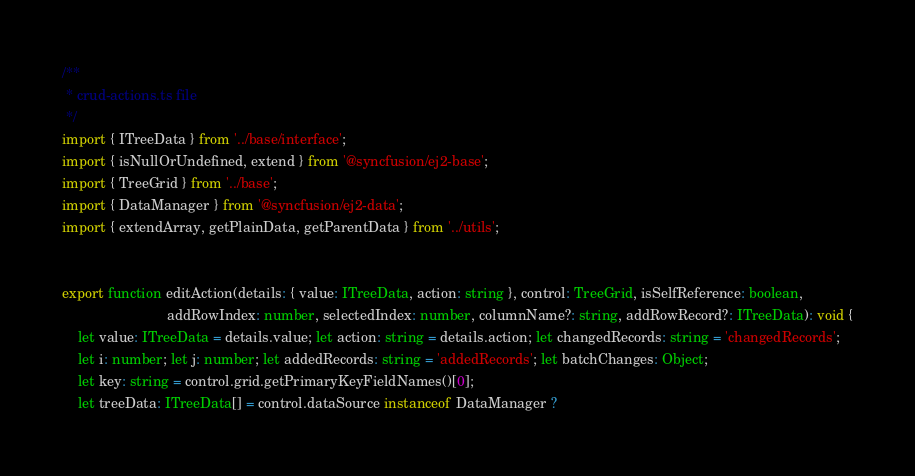<code> <loc_0><loc_0><loc_500><loc_500><_TypeScript_>/**
 * crud-actions.ts file
 */
import { ITreeData } from '../base/interface';
import { isNullOrUndefined, extend } from '@syncfusion/ej2-base';
import { TreeGrid } from '../base';
import { DataManager } from '@syncfusion/ej2-data';
import { extendArray, getPlainData, getParentData } from '../utils';


export function editAction(details: { value: ITreeData, action: string }, control: TreeGrid, isSelfReference: boolean,
                           addRowIndex: number, selectedIndex: number, columnName?: string, addRowRecord?: ITreeData): void {
    let value: ITreeData = details.value; let action: string = details.action; let changedRecords: string = 'changedRecords';
    let i: number; let j: number; let addedRecords: string = 'addedRecords'; let batchChanges: Object;
    let key: string = control.grid.getPrimaryKeyFieldNames()[0];
    let treeData: ITreeData[] = control.dataSource instanceof DataManager ?</code> 